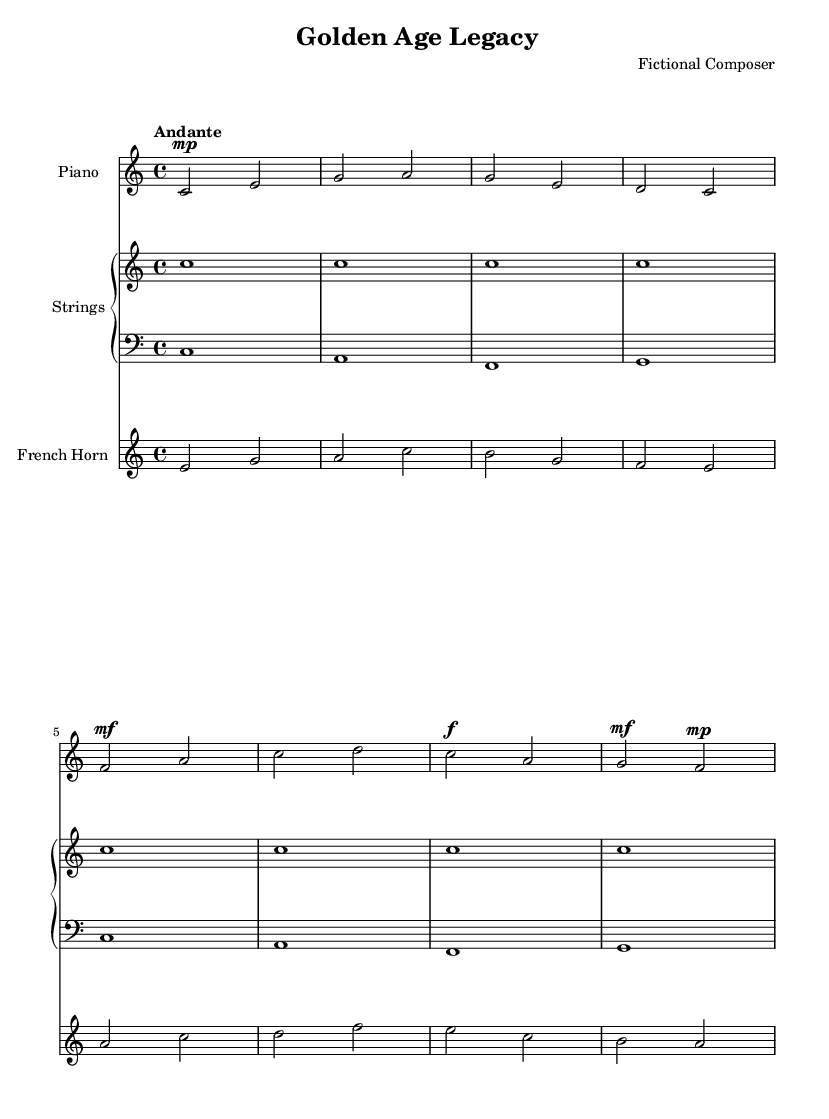What is the key signature of this music? The key signature appears at the beginning of the sheet music after the clef, indicating C major, which has no sharps or flats.
Answer: C major What is the time signature of this music? The time signature is indicated as 4/4 at the beginning of the score, which means there are four beats in each measure.
Answer: 4/4 What is the tempo marking for this music? The tempo marking is noted as "Andante," which indicates a moderate pace, typically around 76-108 beats per minute.
Answer: Andante How many measures are there in the piano part? By counting the measures in the piano staff, we can see there are eight measures in total.
Answer: 8 What instrument plays the bass clef? The bass clef is labeled for the 'Strings' staff, indicating that it is part of the broader arrangement, specifically designed for the lower harmony.
Answer: Strings Which instrument holds the melody in the first section? The treble clef in the piano part suggests it carries the primary melodic line in the first section of the score.
Answer: Piano What dynamic marking is applied to the final measure of the piano part? The dynamic marking indicated in the final measure is "mf" (mezzoforte), suggesting a moderately loud volume for that part of the melody.
Answer: mf 